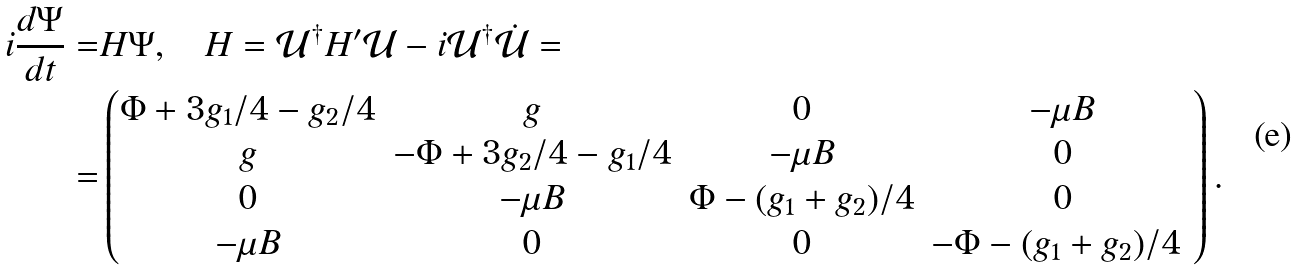<formula> <loc_0><loc_0><loc_500><loc_500>i \frac { d \Psi } { d t } = & H \Psi , \quad H = \mathcal { U } ^ { \dag } H ^ { \prime } \mathcal { U } - i \mathcal { U } ^ { \dag } \dot { \mathcal { U } } = \\ = & \begin{pmatrix} \Phi + 3 g _ { 1 } / 4 - g _ { 2 } / 4 & g & 0 & - \mu B \\ g & - \Phi + 3 g _ { 2 } / 4 - g _ { 1 } / 4 & - \mu B & 0 \\ 0 & - \mu B & \Phi - ( g _ { 1 } + g _ { 2 } ) / 4 & 0 \\ - \mu B & 0 & 0 & - \Phi - ( g _ { 1 } + g _ { 2 } ) / 4 \ \end{pmatrix} .</formula> 